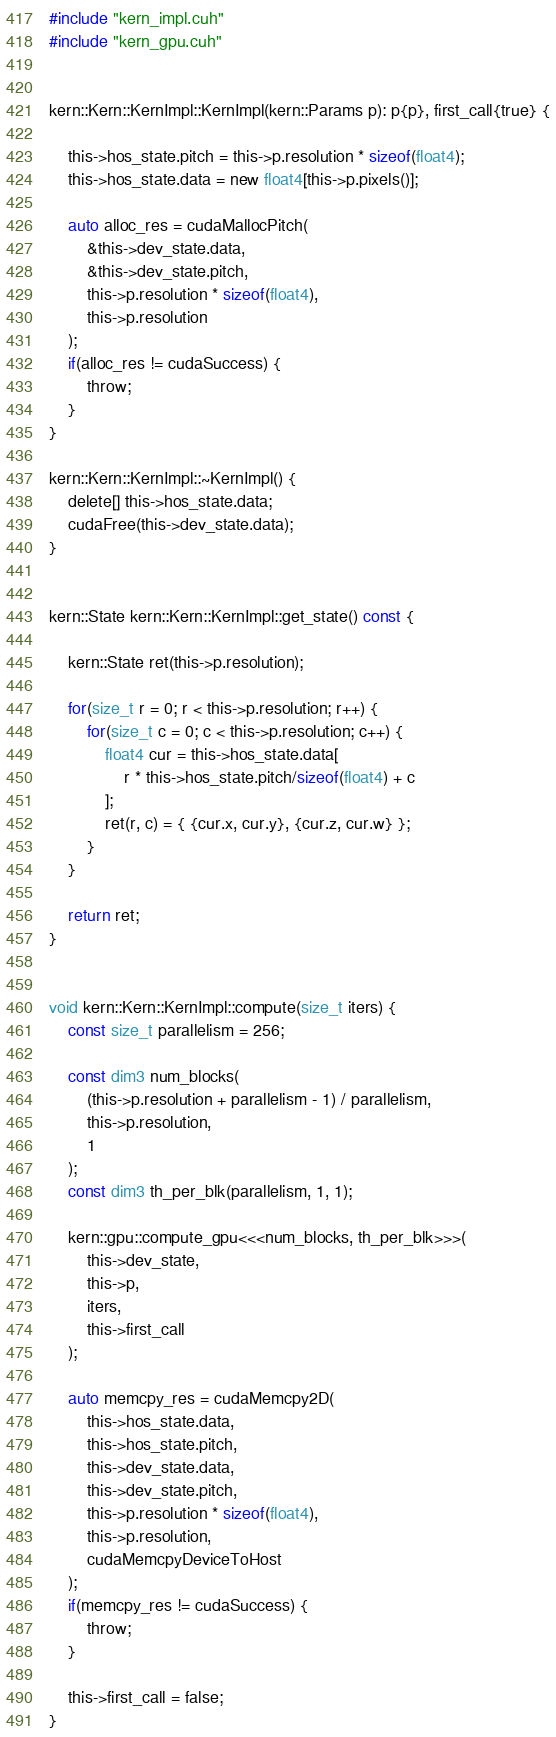<code> <loc_0><loc_0><loc_500><loc_500><_Cuda_>#include "kern_impl.cuh"
#include "kern_gpu.cuh"


kern::Kern::KernImpl::KernImpl(kern::Params p): p{p}, first_call{true} {

    this->hos_state.pitch = this->p.resolution * sizeof(float4);
    this->hos_state.data = new float4[this->p.pixels()];

    auto alloc_res = cudaMallocPitch(
        &this->dev_state.data,
        &this->dev_state.pitch,
        this->p.resolution * sizeof(float4),
        this->p.resolution
    );
    if(alloc_res != cudaSuccess) {
        throw;
    }
}

kern::Kern::KernImpl::~KernImpl() {
    delete[] this->hos_state.data;
    cudaFree(this->dev_state.data);
}


kern::State kern::Kern::KernImpl::get_state() const {

    kern::State ret(this->p.resolution);

    for(size_t r = 0; r < this->p.resolution; r++) {
        for(size_t c = 0; c < this->p.resolution; c++) {
            float4 cur = this->hos_state.data[
                r * this->hos_state.pitch/sizeof(float4) + c
            ];
            ret(r, c) = { {cur.x, cur.y}, {cur.z, cur.w} };
        }
    }

    return ret;
}


void kern::Kern::KernImpl::compute(size_t iters) {
    const size_t parallelism = 256;

    const dim3 num_blocks(
        (this->p.resolution + parallelism - 1) / parallelism,
        this->p.resolution,
        1
    );
    const dim3 th_per_blk(parallelism, 1, 1);

    kern::gpu::compute_gpu<<<num_blocks, th_per_blk>>>(
        this->dev_state,
        this->p,
        iters,
        this->first_call
    );

    auto memcpy_res = cudaMemcpy2D(
        this->hos_state.data,
        this->hos_state.pitch,
        this->dev_state.data,
        this->dev_state.pitch,
        this->p.resolution * sizeof(float4),
        this->p.resolution,
        cudaMemcpyDeviceToHost
    );
    if(memcpy_res != cudaSuccess) {
        throw;
    }

    this->first_call = false;
}
</code> 